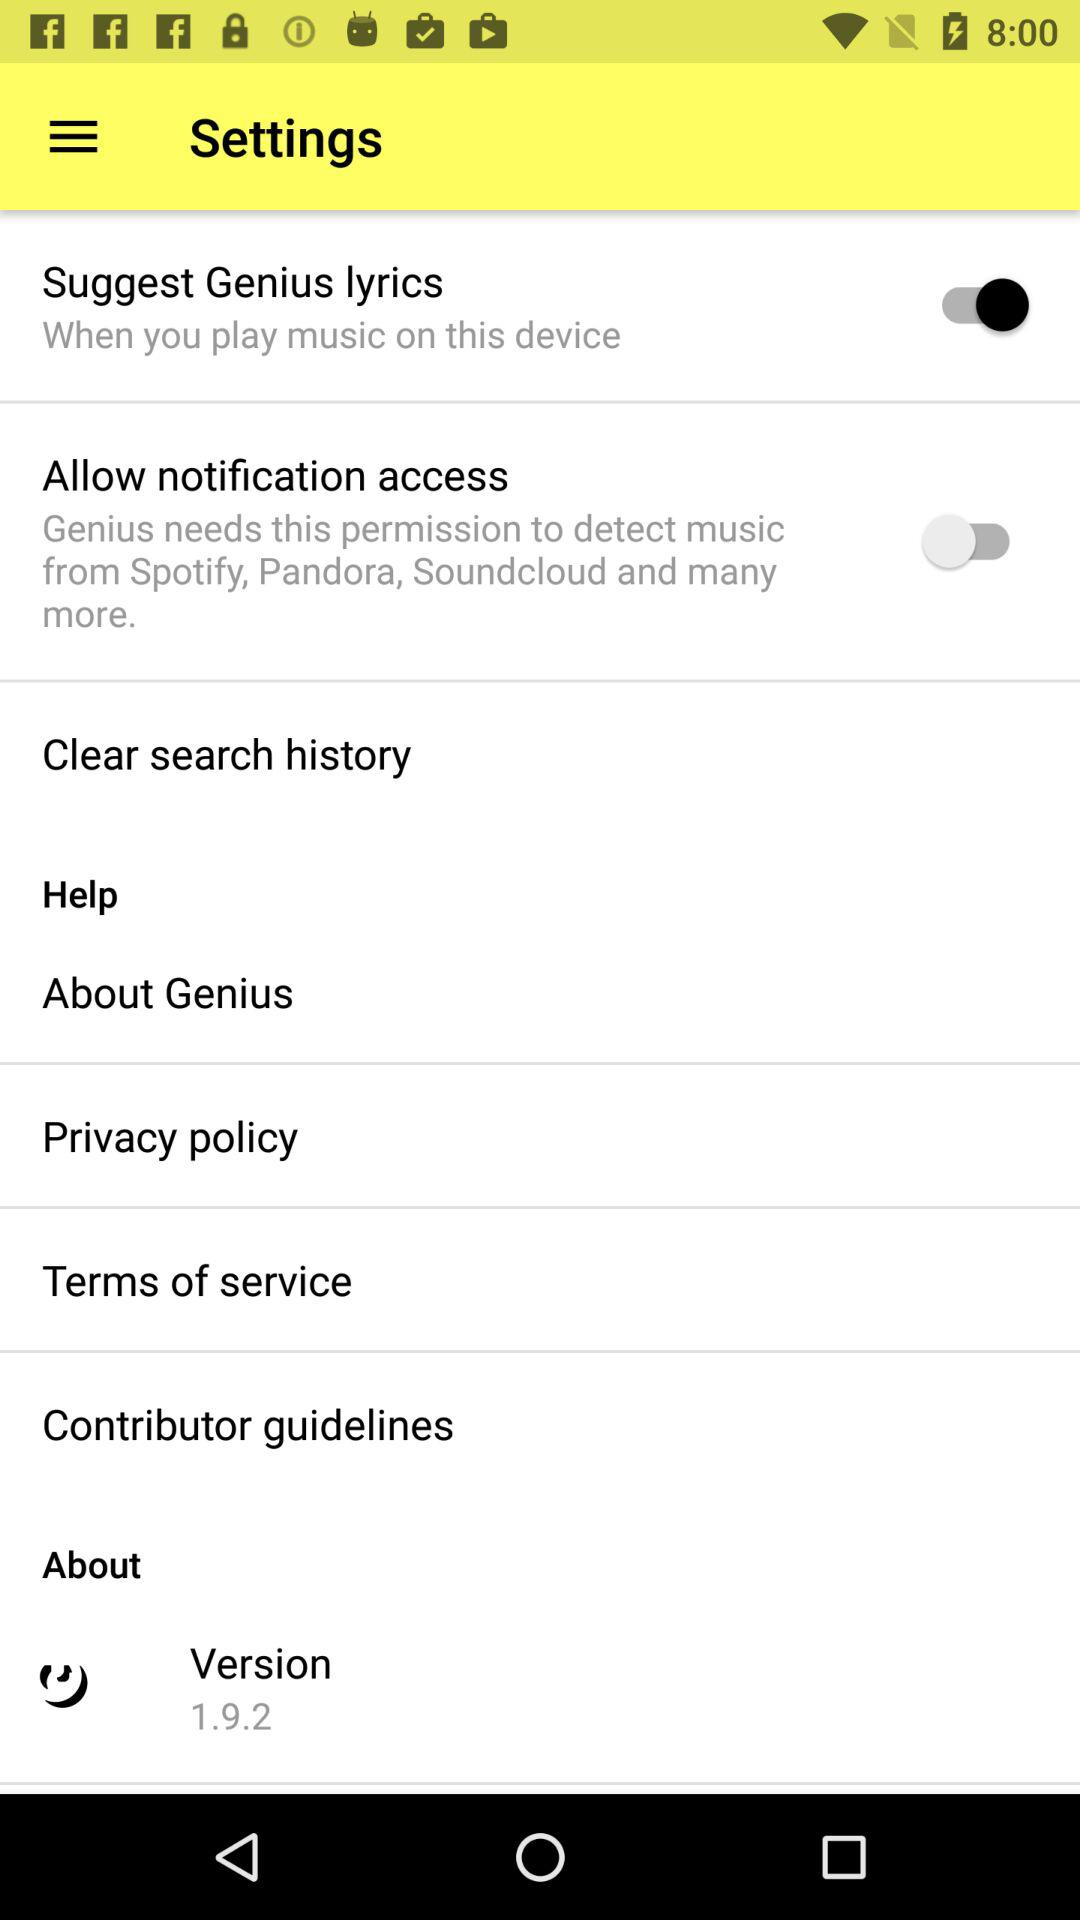What is the status of the "Suggest Genius lyrics"? The status is "on". 